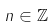Convert formula to latex. <formula><loc_0><loc_0><loc_500><loc_500>n \in \mathbb { Z }</formula> 